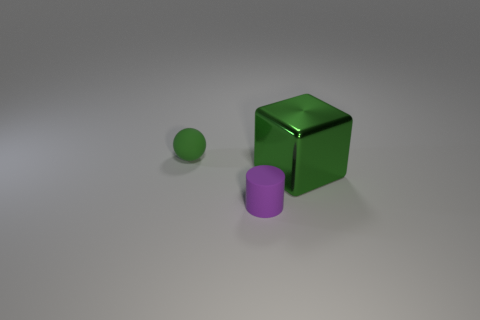Subtract all red cubes. Subtract all red balls. How many cubes are left? 1 Add 3 large red balls. How many objects exist? 6 Subtract all balls. How many objects are left? 2 Subtract 0 cyan balls. How many objects are left? 3 Subtract all small cyan things. Subtract all matte spheres. How many objects are left? 2 Add 1 big green cubes. How many big green cubes are left? 2 Add 3 tiny gray matte objects. How many tiny gray matte objects exist? 3 